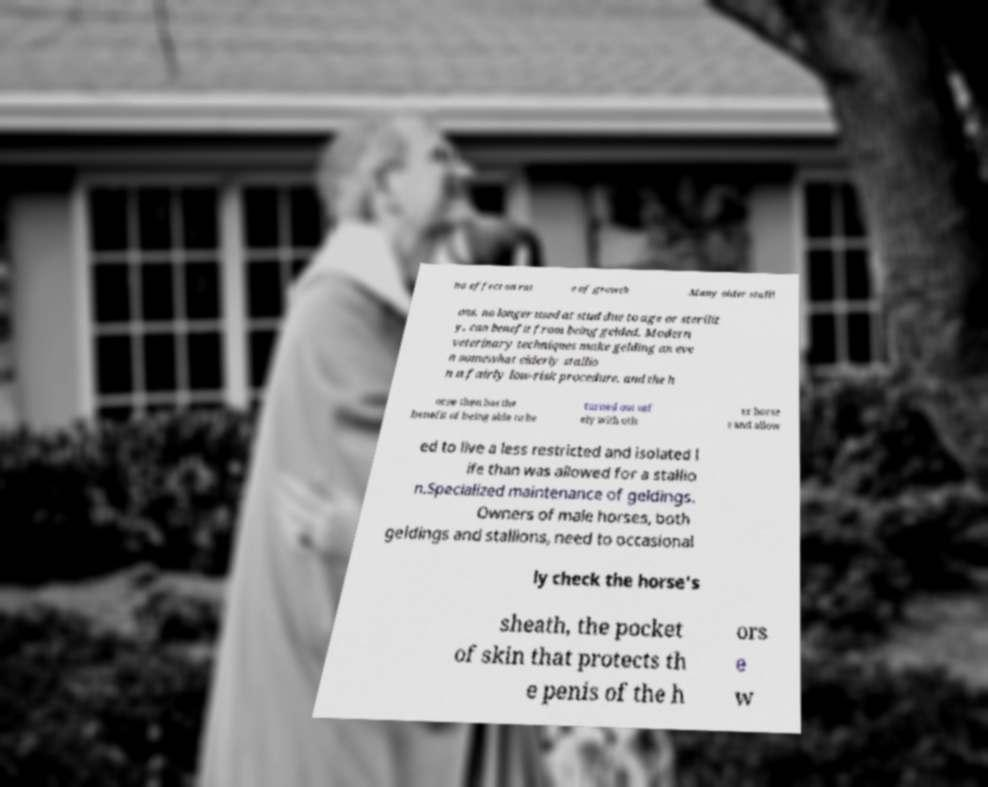Please read and relay the text visible in this image. What does it say? no effect on rat e of growth .Many older stalli ons, no longer used at stud due to age or sterilit y, can benefit from being gelded. Modern veterinary techniques make gelding an eve n somewhat elderly stallio n a fairly low-risk procedure, and the h orse then has the benefit of being able to be turned out saf ely with oth er horse s and allow ed to live a less restricted and isolated l ife than was allowed for a stallio n.Specialized maintenance of geldings. Owners of male horses, both geldings and stallions, need to occasional ly check the horse's sheath, the pocket of skin that protects th e penis of the h ors e w 